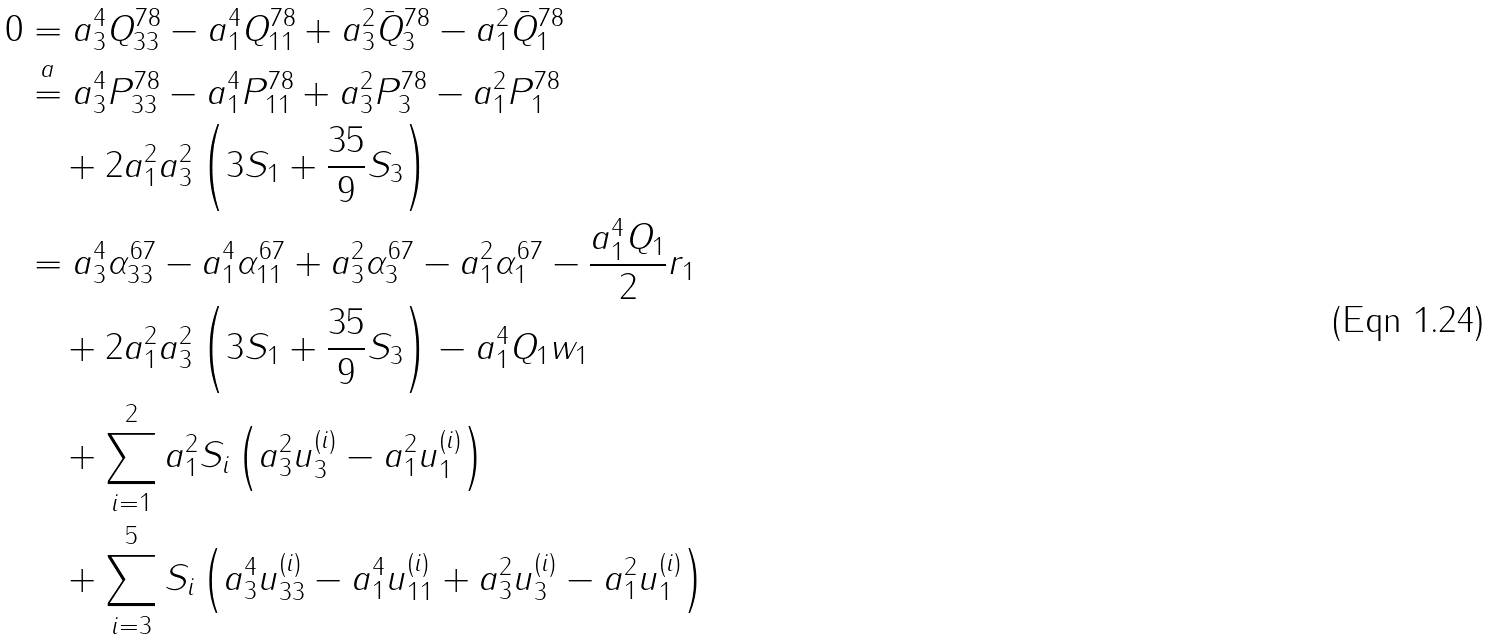Convert formula to latex. <formula><loc_0><loc_0><loc_500><loc_500>0 & = a _ { 3 } ^ { 4 } Q _ { 3 3 } ^ { 7 8 } - a _ { 1 } ^ { 4 } Q _ { 1 1 } ^ { 7 8 } + a _ { 3 } ^ { 2 } \bar { Q } _ { 3 } ^ { 7 8 } - a _ { 1 } ^ { 2 } \bar { Q } _ { 1 } ^ { 7 8 } \\ & \stackrel { a } { = } a _ { 3 } ^ { 4 } P _ { 3 3 } ^ { 7 8 } - a _ { 1 } ^ { 4 } P _ { 1 1 } ^ { 7 8 } + a _ { 3 } ^ { 2 } P _ { 3 } ^ { 7 8 } - a _ { 1 } ^ { 2 } P _ { 1 } ^ { 7 8 } \\ & \quad + 2 a _ { 1 } ^ { 2 } a _ { 3 } ^ { 2 } \left ( 3 S _ { 1 } + \frac { 3 5 } { 9 } S _ { 3 } \right ) \\ & = a _ { 3 } ^ { 4 } \alpha _ { 3 3 } ^ { 6 7 } - a _ { 1 } ^ { 4 } \alpha _ { 1 1 } ^ { 6 7 } + a _ { 3 } ^ { 2 } \alpha _ { 3 } ^ { 6 7 } - a _ { 1 } ^ { 2 } \alpha _ { 1 } ^ { 6 7 } - \frac { a _ { 1 } ^ { 4 } Q _ { 1 } } { 2 } r _ { 1 } \\ & \quad + 2 a _ { 1 } ^ { 2 } a _ { 3 } ^ { 2 } \left ( 3 S _ { 1 } + \frac { 3 5 } { 9 } S _ { 3 } \right ) - a _ { 1 } ^ { 4 } Q _ { 1 } w _ { 1 } \\ & \quad + \sum _ { i = 1 } ^ { 2 } a _ { 1 } ^ { 2 } S _ { i } \left ( a _ { 3 } ^ { 2 } u _ { 3 } ^ { ( i ) } - a _ { 1 } ^ { 2 } u _ { 1 } ^ { ( i ) } \right ) \\ & \quad + \sum _ { i = 3 } ^ { 5 } S _ { i } \left ( a _ { 3 } ^ { 4 } u _ { 3 3 } ^ { ( i ) } - a _ { 1 } ^ { 4 } u _ { 1 1 } ^ { ( i ) } + a _ { 3 } ^ { 2 } u _ { 3 } ^ { ( i ) } - a _ { 1 } ^ { 2 } u _ { 1 } ^ { ( i ) } \right )</formula> 